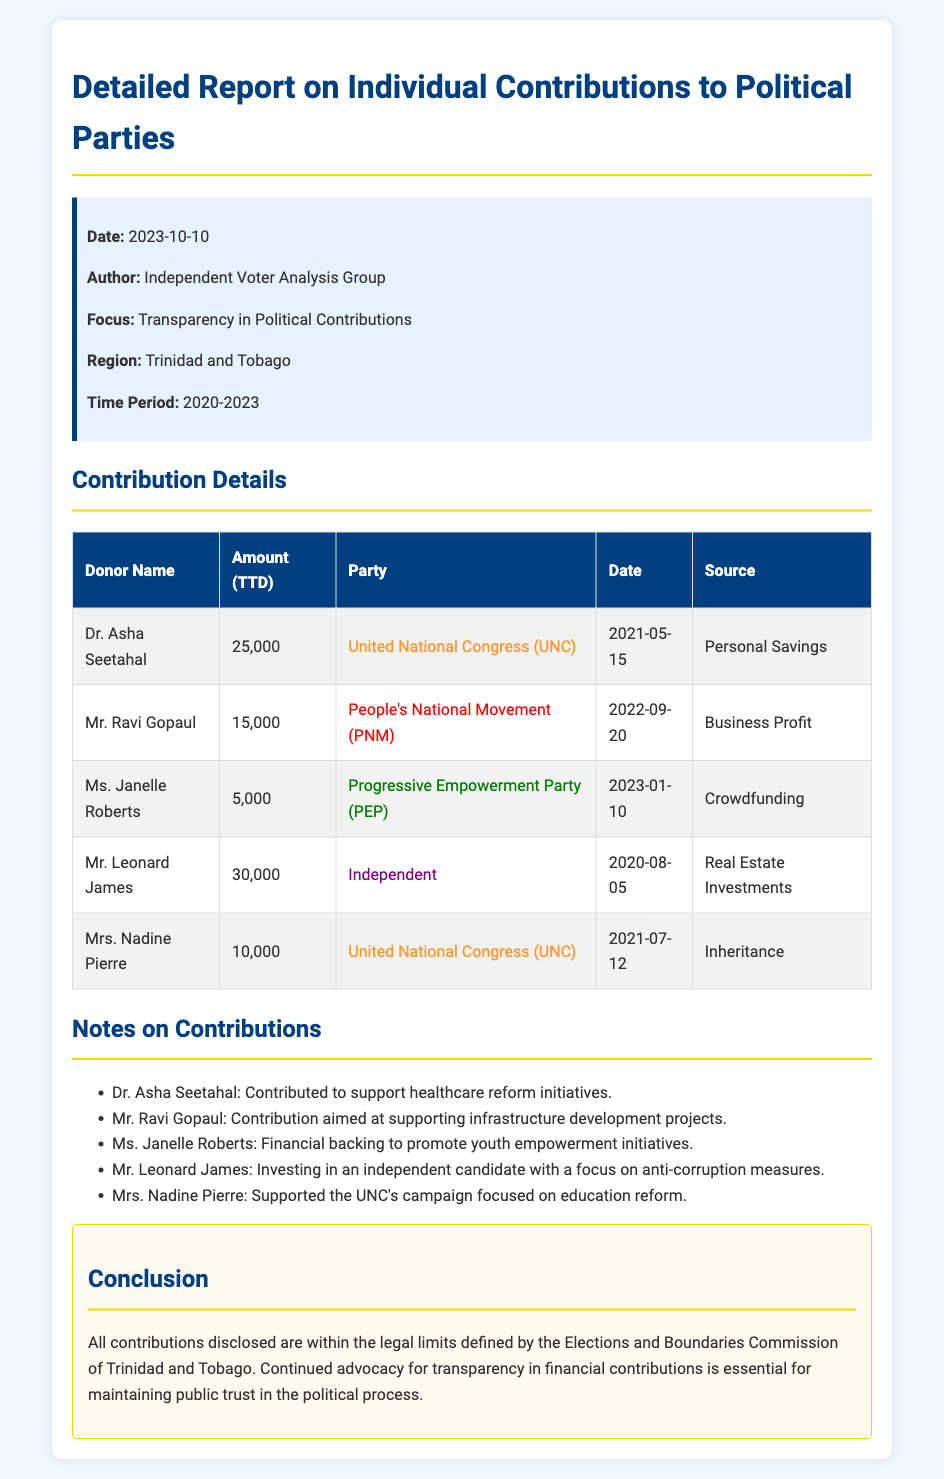What is the date of the report? The date of the report is provided in the document's report information section.
Answer: 2023-10-10 Who contributed to the People's National Movement? The document lists contributions and indicates which political party each donor supported.
Answer: Mr. Ravi Gopaul What is the total amount contributed by Dr. Asha Seetahal? The amount is directly stated in the contribution details of the document.
Answer: 25,000 What was the source of Mr. Leonard James's contribution? The document specifies the source of his contribution in the details section.
Answer: Real Estate Investments Which party received a contribution aimed at youth empowerment initiatives? The document includes a note specifying the purpose of Ms. Janelle Roberts' contribution.
Answer: Progressive Empowerment Party (PEP) How many contributions are listed in the document? The total number of contributions can be determined by counting the entries in the contribution details table.
Answer: 5 What is the focus of the advocacy for transparency mentioned in the conclusion? The conclusion highlights the importance of maintaining public trust in the political process through transparency.
Answer: Public trust Who supports education reform according to the document? The supporting individual for education reform is noted in the contributions and associated reasons.
Answer: Mrs. Nadine Pierre 